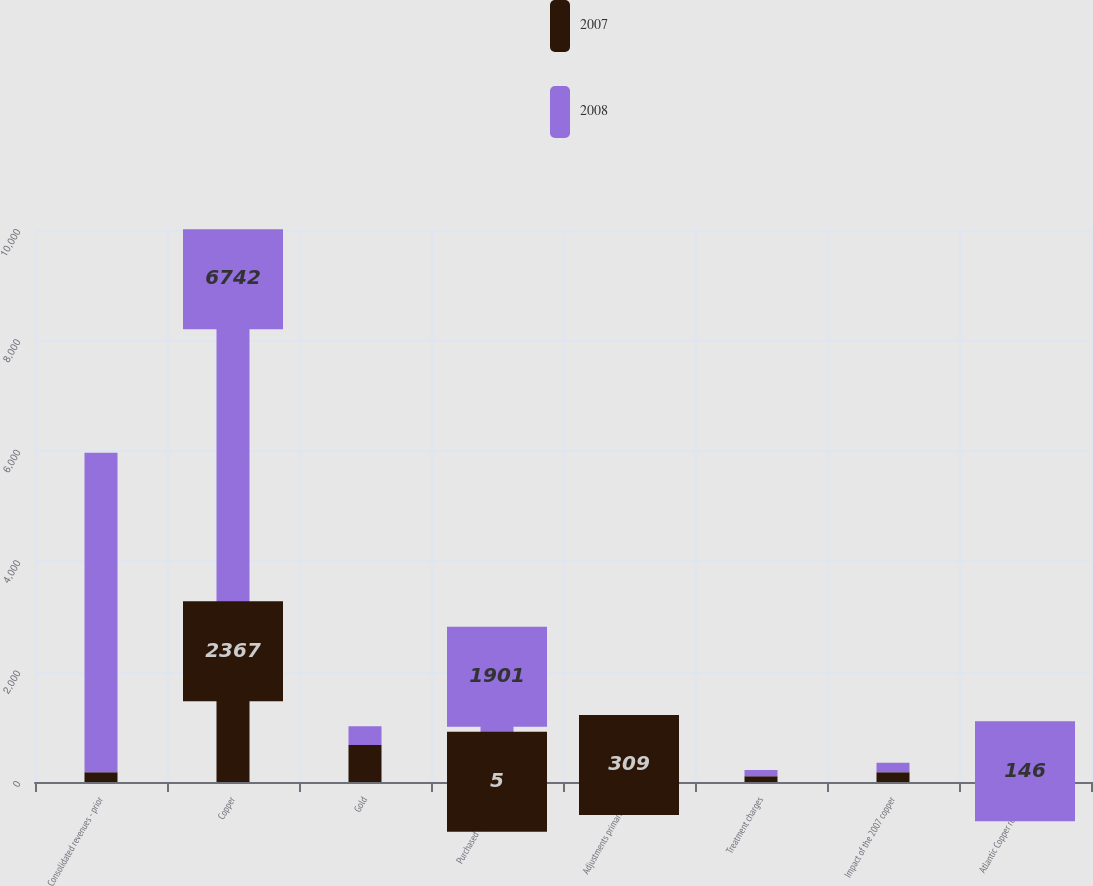<chart> <loc_0><loc_0><loc_500><loc_500><stacked_bar_chart><ecel><fcel>Consolidated revenues - prior<fcel>Copper<fcel>Gold<fcel>Purchased copper and<fcel>Adjustments primarily for<fcel>Treatment charges<fcel>Impact of the 2007 copper<fcel>Atlantic Copper revenues<nl><fcel>2007<fcel>175<fcel>2367<fcel>671<fcel>5<fcel>309<fcel>104<fcel>175<fcel>47<nl><fcel>2008<fcel>5791<fcel>6742<fcel>341<fcel>1901<fcel>175<fcel>114<fcel>175<fcel>146<nl></chart> 